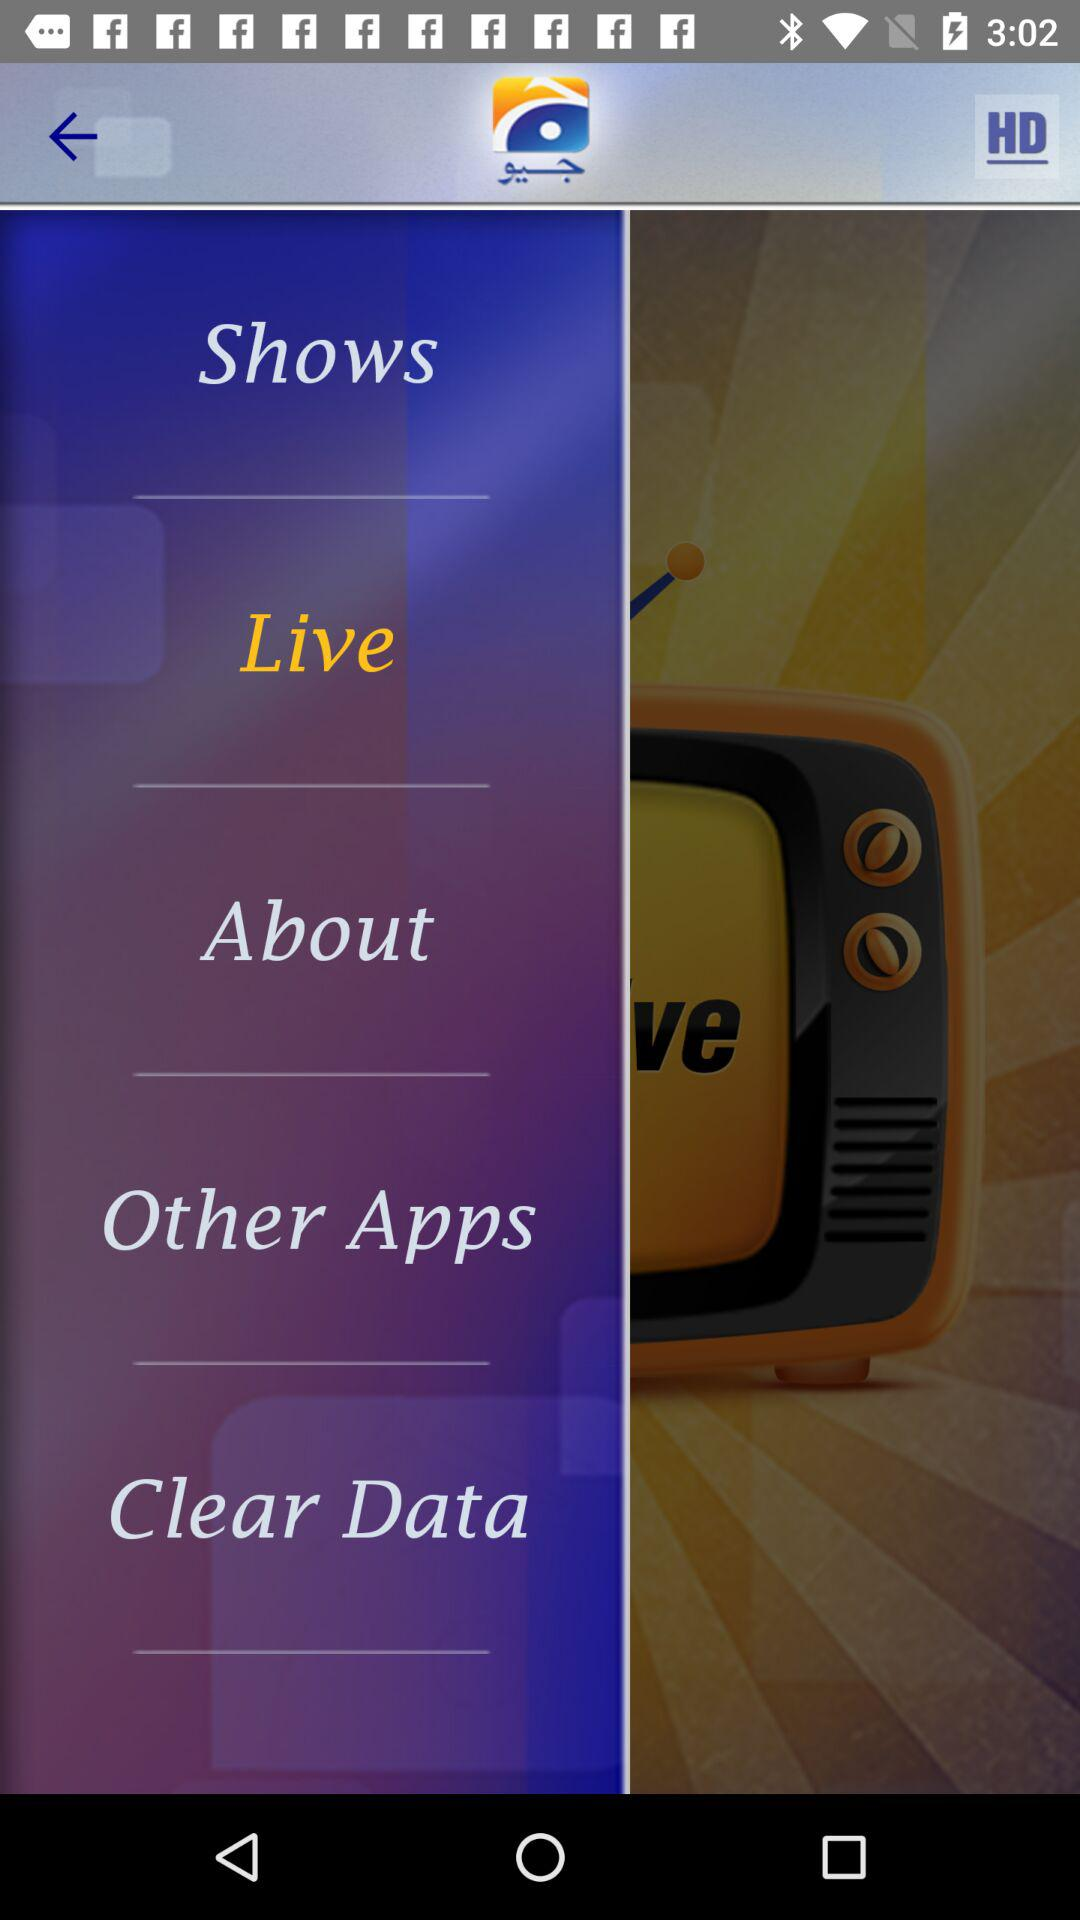Which item is selected? The selected item is "Live". 